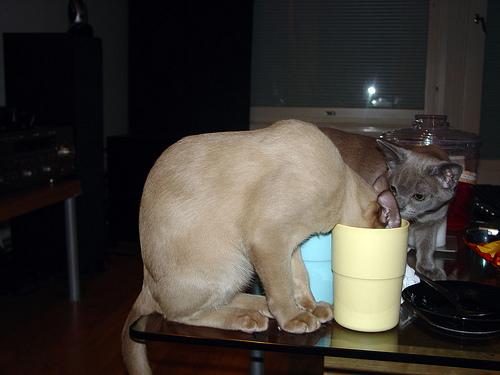Who is going to be in trouble when the owners come home?
Concise answer only. Cats. Where is the brown cat's head?
Write a very short answer. In cup. What is the cat drinking out of?
Give a very brief answer. Cup. What is the dog laying in?
Quick response, please. Table. How many cats are on the table?
Answer briefly. 2. What is next to the cup?
Give a very brief answer. Cat. 